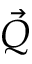<formula> <loc_0><loc_0><loc_500><loc_500>\vec { Q }</formula> 